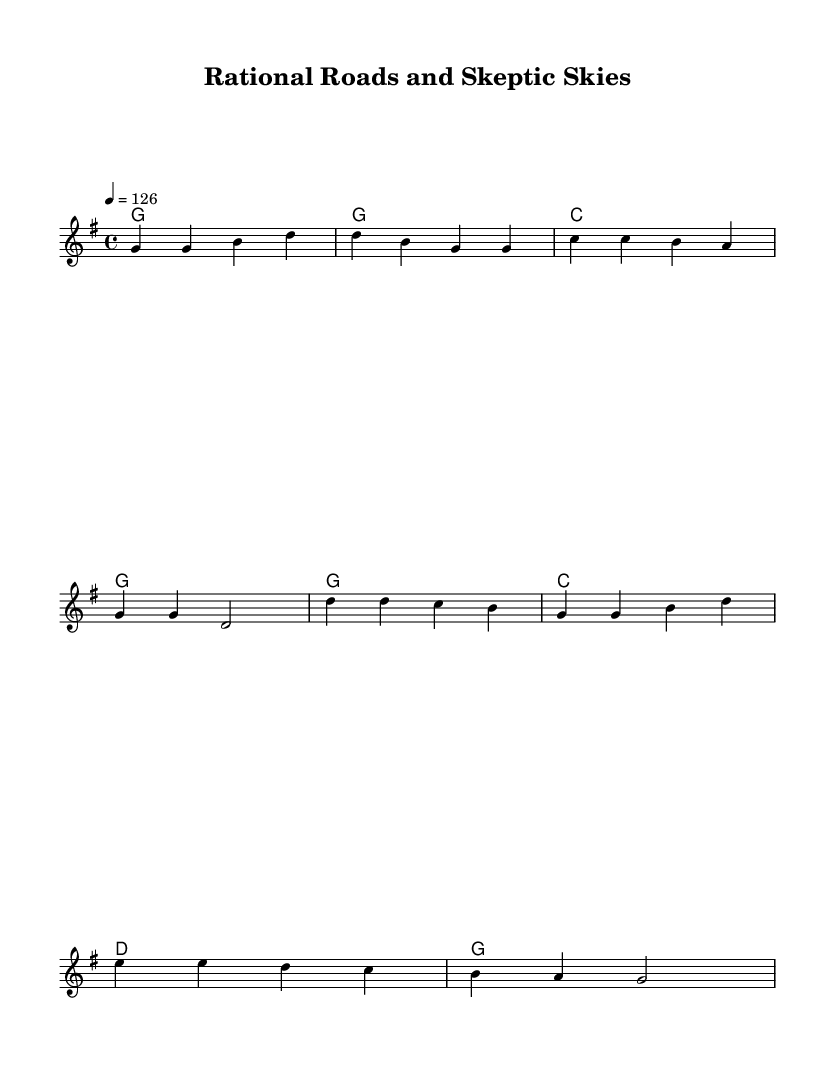What is the key signature of this music? The key signature is G major, which has one sharp (F#). This can be confirmed by looking for the sharp signs in the key signature at the beginning of the staff.
Answer: G major What is the time signature of this music? The time signature is 4/4, which is indicated by the two numbers at the beginning of the score. The top number (4) indicates four beats per measure, and the bottom number (4) indicates a quarter note gets one beat.
Answer: 4/4 What is the tempo marking of this music? The tempo marking is 126 beats per minute, indicated by the marking "4 = 126" at the beginning of the score. This means each quarter note should be played at that speed.
Answer: 126 How many measures are in the verse? There are four measures in the verse, counted by counting the groups of notes and the vertical lines (bars) that separate them. The verse consists of the first four lines of music notation.
Answer: 4 What musical mode is used in the chorus? The chorus primarily uses major chords, specifically the G, C, and D major chords, which are characteristic of a major mode composition. The overall sound and harmony suggest a feeling of resolution and positivity typical in country rock music.
Answer: Major mode What is the main theme of the lyrics? The main theme of the lyrics emphasizes rational thinking and skepticism, as seen through phrases like "no superstition in our way" and "we're riding high on reason's wind." This reflects a celebration of logic over belief.
Answer: Rational thinking and skepticism Which section contains the repetition of the main idea? The chorus contains the repetition of the main idea, as it revisits the key themes introduced in the verse, emphasizing feelings related to reason and the power of the mind. The lyrical structure reinforces this idea through repeated phrases.
Answer: Chorus 